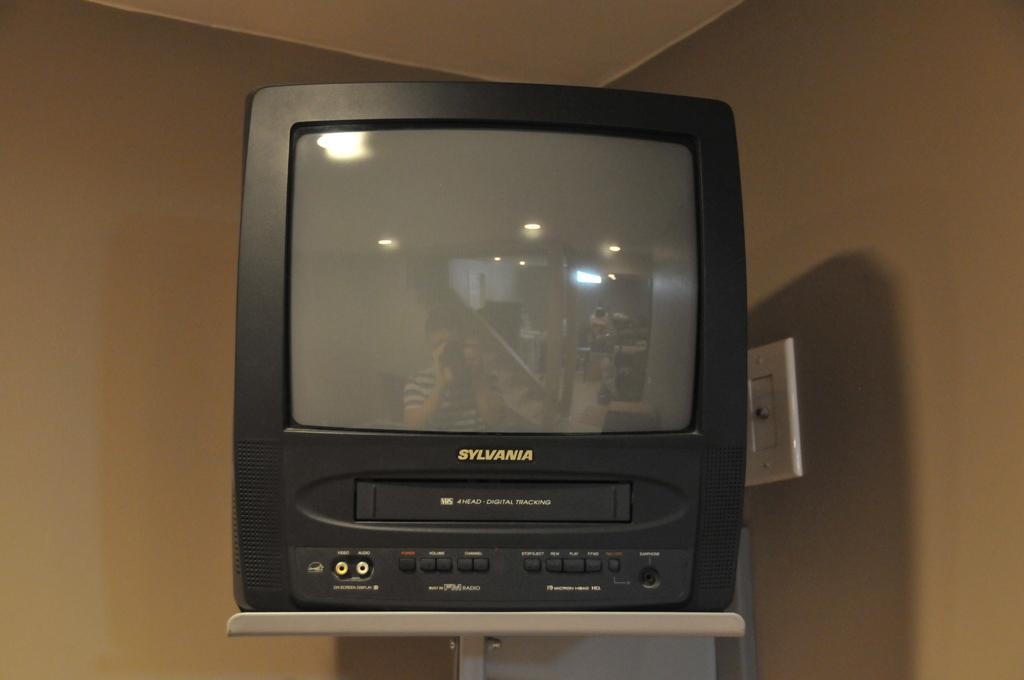<image>
Present a compact description of the photo's key features. A black TV on a wall mount says Sylvania on the front. 